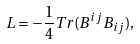<formula> <loc_0><loc_0><loc_500><loc_500>L = - \frac { 1 } { 4 } T r ( B ^ { i j } B _ { i j } ) ,</formula> 